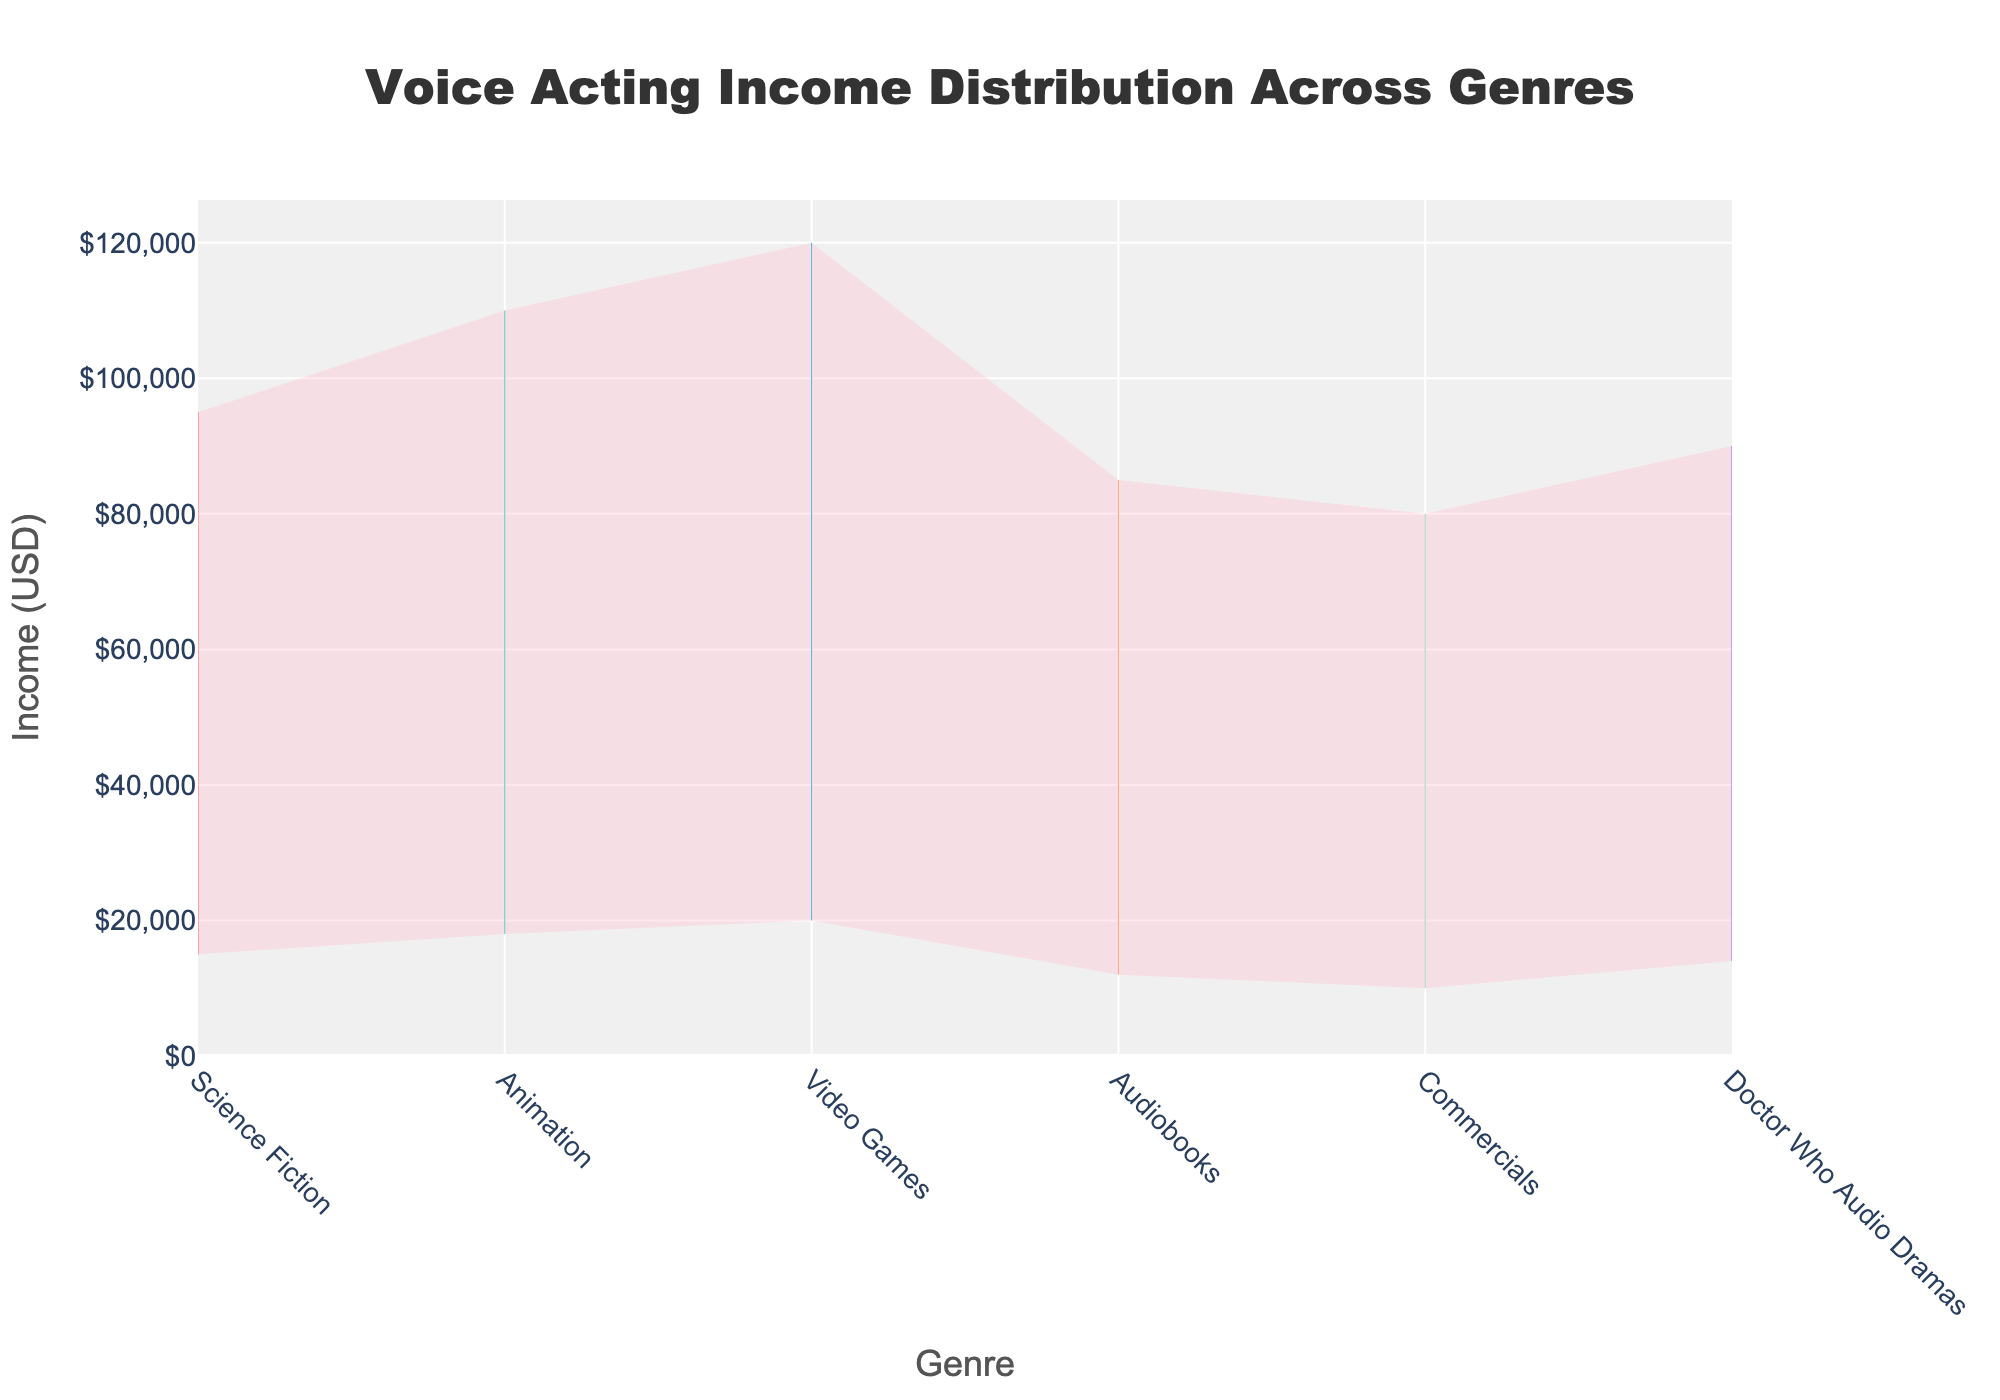What does the chart title indicate? The chart title is usually displayed at the top of the figure and provides a brief summary of what the chart represents.
Answer: Voice Acting Income Distribution Across Genres Which genre has the highest maximum income? To find the highest maximum income, look at the maximum value on the y-axis of each genre and identify which is the highest.
Answer: Video Games What is the median income for Animation genre? The median value is the middle point in the distribution. For Animation, check the third value in the y-axis labels for its respective line.
Answer: $48,000 By how much does the upper quartile income for Doctor Who Audio Dramas exceed that of Audiobooks? First, identify the upper quartile incomes for both genres, then subtract the value for Audiobooks from that of Doctor Who Audio Dramas.
Answer: $4,000 What is the difference between the lower quartile incomes of Commercials and Science Fiction? The lower quartile for each genre is the second value on the y-axis labels. Subtract the lower quartile of Commercials from that of Science Fiction.
Answer: $6,000 Which genre shows the largest range in income distribution? The range is calculated by subtracting the minimum value from the maximum value for each genre. Compare all genres to find the one with the largest range.
Answer: Video Games Comparing the maximum incomes, how much more does an Animation voice actor make than a Doctor Who Audio Dramas voice actor? Find the maximum values for both Animation and Doctor Who Audio Dramas, then subtract the latter from the former.
Answer: $20,000 What is the income range between the lower quartile and upper quartile for Science Fiction? The income range between the lower and upper quartiles can be calculated by subtracting the lower quartile value from the upper quartile value for Science Fiction.
Answer: $37,000 Which genre has the lowest minimum income? Identify the smallest minimum income value among all the genres.
Answer: Commercials Is the median income for Video Games higher than the upper quartile income for Science Fiction? Compare the median income value for Video Games with the upper quartile income value for Science Fiction to determine if it's higher.
Answer: Yes 